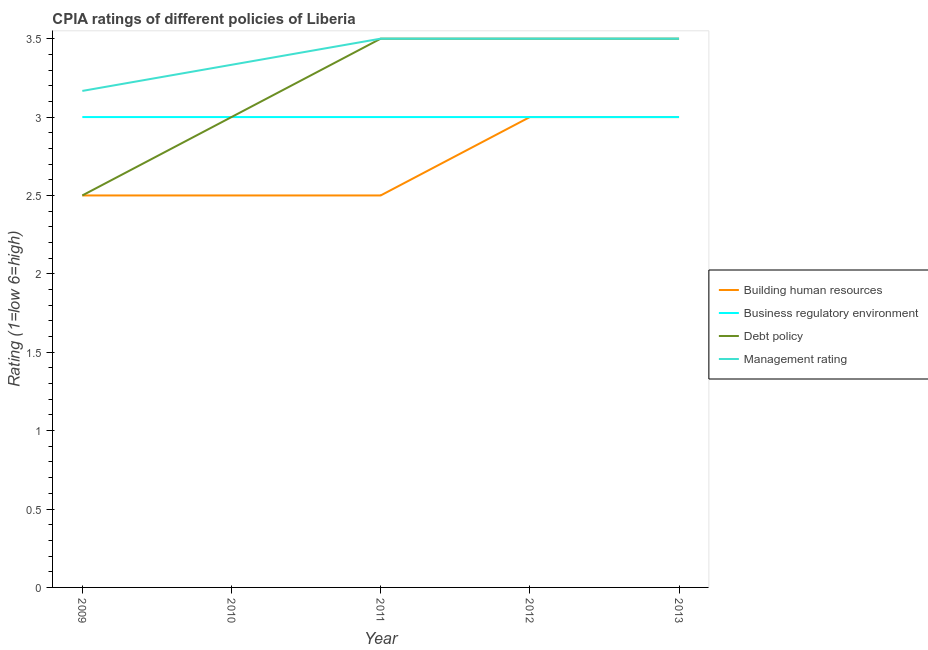How many different coloured lines are there?
Give a very brief answer. 4. Does the line corresponding to cpia rating of debt policy intersect with the line corresponding to cpia rating of management?
Provide a short and direct response. Yes. Across all years, what is the maximum cpia rating of management?
Your response must be concise. 3.5. Across all years, what is the minimum cpia rating of business regulatory environment?
Provide a succinct answer. 3. What is the difference between the cpia rating of building human resources in 2009 and that in 2012?
Offer a terse response. -0.5. What is the ratio of the cpia rating of business regulatory environment in 2011 to that in 2013?
Provide a short and direct response. 1. Is the difference between the cpia rating of building human resources in 2010 and 2011 greater than the difference between the cpia rating of management in 2010 and 2011?
Your answer should be very brief. Yes. What is the difference between the highest and the second highest cpia rating of building human resources?
Your answer should be compact. 0. What is the difference between the highest and the lowest cpia rating of debt policy?
Give a very brief answer. 1. In how many years, is the cpia rating of management greater than the average cpia rating of management taken over all years?
Your answer should be compact. 3. Is the sum of the cpia rating of building human resources in 2011 and 2012 greater than the maximum cpia rating of business regulatory environment across all years?
Keep it short and to the point. Yes. Does the cpia rating of management monotonically increase over the years?
Your response must be concise. No. Is the cpia rating of building human resources strictly greater than the cpia rating of debt policy over the years?
Provide a succinct answer. No. Is the cpia rating of debt policy strictly less than the cpia rating of business regulatory environment over the years?
Make the answer very short. No. Are the values on the major ticks of Y-axis written in scientific E-notation?
Offer a very short reply. No. Does the graph contain grids?
Your answer should be very brief. No. Where does the legend appear in the graph?
Provide a succinct answer. Center right. How many legend labels are there?
Provide a short and direct response. 4. What is the title of the graph?
Keep it short and to the point. CPIA ratings of different policies of Liberia. Does "Business regulatory environment" appear as one of the legend labels in the graph?
Provide a short and direct response. Yes. What is the Rating (1=low 6=high) in Building human resources in 2009?
Offer a very short reply. 2.5. What is the Rating (1=low 6=high) in Business regulatory environment in 2009?
Your answer should be compact. 3. What is the Rating (1=low 6=high) of Management rating in 2009?
Offer a very short reply. 3.17. What is the Rating (1=low 6=high) in Debt policy in 2010?
Keep it short and to the point. 3. What is the Rating (1=low 6=high) in Management rating in 2010?
Your answer should be very brief. 3.33. What is the Rating (1=low 6=high) of Business regulatory environment in 2011?
Make the answer very short. 3. What is the Rating (1=low 6=high) of Debt policy in 2011?
Your response must be concise. 3.5. What is the Rating (1=low 6=high) in Management rating in 2011?
Make the answer very short. 3.5. What is the Rating (1=low 6=high) in Building human resources in 2012?
Offer a terse response. 3. What is the Rating (1=low 6=high) in Debt policy in 2012?
Make the answer very short. 3.5. What is the Rating (1=low 6=high) in Management rating in 2012?
Make the answer very short. 3.5. What is the Rating (1=low 6=high) of Building human resources in 2013?
Your answer should be compact. 3. What is the Rating (1=low 6=high) in Business regulatory environment in 2013?
Provide a succinct answer. 3. What is the Rating (1=low 6=high) of Management rating in 2013?
Offer a terse response. 3.5. Across all years, what is the maximum Rating (1=low 6=high) of Building human resources?
Offer a terse response. 3. Across all years, what is the maximum Rating (1=low 6=high) of Business regulatory environment?
Your response must be concise. 3. Across all years, what is the maximum Rating (1=low 6=high) in Debt policy?
Provide a succinct answer. 3.5. Across all years, what is the minimum Rating (1=low 6=high) in Building human resources?
Make the answer very short. 2.5. Across all years, what is the minimum Rating (1=low 6=high) of Debt policy?
Keep it short and to the point. 2.5. Across all years, what is the minimum Rating (1=low 6=high) in Management rating?
Your response must be concise. 3.17. What is the total Rating (1=low 6=high) in Building human resources in the graph?
Offer a terse response. 13.5. What is the total Rating (1=low 6=high) in Business regulatory environment in the graph?
Offer a terse response. 15. What is the difference between the Rating (1=low 6=high) of Business regulatory environment in 2009 and that in 2010?
Give a very brief answer. 0. What is the difference between the Rating (1=low 6=high) of Building human resources in 2009 and that in 2011?
Offer a terse response. 0. What is the difference between the Rating (1=low 6=high) of Business regulatory environment in 2009 and that in 2011?
Provide a succinct answer. 0. What is the difference between the Rating (1=low 6=high) of Debt policy in 2009 and that in 2011?
Ensure brevity in your answer.  -1. What is the difference between the Rating (1=low 6=high) of Debt policy in 2009 and that in 2012?
Your response must be concise. -1. What is the difference between the Rating (1=low 6=high) of Management rating in 2009 and that in 2012?
Your response must be concise. -0.33. What is the difference between the Rating (1=low 6=high) of Building human resources in 2010 and that in 2011?
Give a very brief answer. 0. What is the difference between the Rating (1=low 6=high) in Management rating in 2010 and that in 2011?
Ensure brevity in your answer.  -0.17. What is the difference between the Rating (1=low 6=high) of Management rating in 2010 and that in 2012?
Keep it short and to the point. -0.17. What is the difference between the Rating (1=low 6=high) of Business regulatory environment in 2010 and that in 2013?
Provide a succinct answer. 0. What is the difference between the Rating (1=low 6=high) of Building human resources in 2011 and that in 2012?
Offer a very short reply. -0.5. What is the difference between the Rating (1=low 6=high) of Management rating in 2011 and that in 2012?
Your answer should be compact. 0. What is the difference between the Rating (1=low 6=high) of Building human resources in 2011 and that in 2013?
Keep it short and to the point. -0.5. What is the difference between the Rating (1=low 6=high) in Business regulatory environment in 2011 and that in 2013?
Ensure brevity in your answer.  0. What is the difference between the Rating (1=low 6=high) of Building human resources in 2012 and that in 2013?
Your response must be concise. 0. What is the difference between the Rating (1=low 6=high) in Business regulatory environment in 2012 and that in 2013?
Keep it short and to the point. 0. What is the difference between the Rating (1=low 6=high) in Management rating in 2012 and that in 2013?
Give a very brief answer. 0. What is the difference between the Rating (1=low 6=high) in Building human resources in 2009 and the Rating (1=low 6=high) in Management rating in 2010?
Keep it short and to the point. -0.83. What is the difference between the Rating (1=low 6=high) in Business regulatory environment in 2009 and the Rating (1=low 6=high) in Management rating in 2010?
Give a very brief answer. -0.33. What is the difference between the Rating (1=low 6=high) of Building human resources in 2009 and the Rating (1=low 6=high) of Business regulatory environment in 2011?
Provide a short and direct response. -0.5. What is the difference between the Rating (1=low 6=high) in Building human resources in 2009 and the Rating (1=low 6=high) in Debt policy in 2011?
Keep it short and to the point. -1. What is the difference between the Rating (1=low 6=high) in Building human resources in 2009 and the Rating (1=low 6=high) in Business regulatory environment in 2012?
Give a very brief answer. -0.5. What is the difference between the Rating (1=low 6=high) in Building human resources in 2009 and the Rating (1=low 6=high) in Debt policy in 2012?
Provide a succinct answer. -1. What is the difference between the Rating (1=low 6=high) of Building human resources in 2009 and the Rating (1=low 6=high) of Management rating in 2012?
Keep it short and to the point. -1. What is the difference between the Rating (1=low 6=high) of Business regulatory environment in 2009 and the Rating (1=low 6=high) of Debt policy in 2012?
Keep it short and to the point. -0.5. What is the difference between the Rating (1=low 6=high) in Business regulatory environment in 2009 and the Rating (1=low 6=high) in Management rating in 2012?
Provide a short and direct response. -0.5. What is the difference between the Rating (1=low 6=high) of Business regulatory environment in 2009 and the Rating (1=low 6=high) of Management rating in 2013?
Provide a short and direct response. -0.5. What is the difference between the Rating (1=low 6=high) of Building human resources in 2010 and the Rating (1=low 6=high) of Business regulatory environment in 2011?
Provide a succinct answer. -0.5. What is the difference between the Rating (1=low 6=high) of Building human resources in 2010 and the Rating (1=low 6=high) of Management rating in 2011?
Keep it short and to the point. -1. What is the difference between the Rating (1=low 6=high) in Business regulatory environment in 2010 and the Rating (1=low 6=high) in Debt policy in 2011?
Provide a succinct answer. -0.5. What is the difference between the Rating (1=low 6=high) of Building human resources in 2010 and the Rating (1=low 6=high) of Business regulatory environment in 2012?
Give a very brief answer. -0.5. What is the difference between the Rating (1=low 6=high) in Debt policy in 2010 and the Rating (1=low 6=high) in Management rating in 2012?
Provide a short and direct response. -0.5. What is the difference between the Rating (1=low 6=high) of Building human resources in 2010 and the Rating (1=low 6=high) of Business regulatory environment in 2013?
Keep it short and to the point. -0.5. What is the difference between the Rating (1=low 6=high) in Building human resources in 2011 and the Rating (1=low 6=high) in Business regulatory environment in 2012?
Give a very brief answer. -0.5. What is the difference between the Rating (1=low 6=high) of Business regulatory environment in 2011 and the Rating (1=low 6=high) of Debt policy in 2012?
Your answer should be very brief. -0.5. What is the difference between the Rating (1=low 6=high) of Business regulatory environment in 2011 and the Rating (1=low 6=high) of Management rating in 2012?
Keep it short and to the point. -0.5. What is the difference between the Rating (1=low 6=high) of Building human resources in 2011 and the Rating (1=low 6=high) of Management rating in 2013?
Give a very brief answer. -1. What is the difference between the Rating (1=low 6=high) in Business regulatory environment in 2011 and the Rating (1=low 6=high) in Debt policy in 2013?
Your answer should be compact. -0.5. What is the difference between the Rating (1=low 6=high) of Business regulatory environment in 2011 and the Rating (1=low 6=high) of Management rating in 2013?
Your answer should be compact. -0.5. What is the difference between the Rating (1=low 6=high) in Debt policy in 2011 and the Rating (1=low 6=high) in Management rating in 2013?
Your answer should be very brief. 0. What is the difference between the Rating (1=low 6=high) in Business regulatory environment in 2012 and the Rating (1=low 6=high) in Debt policy in 2013?
Provide a short and direct response. -0.5. What is the average Rating (1=low 6=high) of Building human resources per year?
Offer a very short reply. 2.7. In the year 2009, what is the difference between the Rating (1=low 6=high) in Building human resources and Rating (1=low 6=high) in Debt policy?
Keep it short and to the point. 0. In the year 2009, what is the difference between the Rating (1=low 6=high) of Business regulatory environment and Rating (1=low 6=high) of Debt policy?
Make the answer very short. 0.5. In the year 2009, what is the difference between the Rating (1=low 6=high) of Business regulatory environment and Rating (1=low 6=high) of Management rating?
Your answer should be compact. -0.17. In the year 2010, what is the difference between the Rating (1=low 6=high) in Building human resources and Rating (1=low 6=high) in Management rating?
Make the answer very short. -0.83. In the year 2010, what is the difference between the Rating (1=low 6=high) of Business regulatory environment and Rating (1=low 6=high) of Management rating?
Your response must be concise. -0.33. In the year 2011, what is the difference between the Rating (1=low 6=high) of Building human resources and Rating (1=low 6=high) of Debt policy?
Keep it short and to the point. -1. In the year 2011, what is the difference between the Rating (1=low 6=high) of Debt policy and Rating (1=low 6=high) of Management rating?
Your response must be concise. 0. In the year 2012, what is the difference between the Rating (1=low 6=high) of Building human resources and Rating (1=low 6=high) of Debt policy?
Your answer should be very brief. -0.5. In the year 2012, what is the difference between the Rating (1=low 6=high) in Building human resources and Rating (1=low 6=high) in Management rating?
Provide a succinct answer. -0.5. In the year 2012, what is the difference between the Rating (1=low 6=high) in Business regulatory environment and Rating (1=low 6=high) in Management rating?
Your answer should be very brief. -0.5. In the year 2012, what is the difference between the Rating (1=low 6=high) in Debt policy and Rating (1=low 6=high) in Management rating?
Give a very brief answer. 0. In the year 2013, what is the difference between the Rating (1=low 6=high) in Building human resources and Rating (1=low 6=high) in Business regulatory environment?
Ensure brevity in your answer.  0. In the year 2013, what is the difference between the Rating (1=low 6=high) in Building human resources and Rating (1=low 6=high) in Debt policy?
Offer a very short reply. -0.5. In the year 2013, what is the difference between the Rating (1=low 6=high) in Business regulatory environment and Rating (1=low 6=high) in Debt policy?
Offer a terse response. -0.5. What is the ratio of the Rating (1=low 6=high) in Building human resources in 2009 to that in 2010?
Provide a succinct answer. 1. What is the ratio of the Rating (1=low 6=high) in Business regulatory environment in 2009 to that in 2010?
Provide a succinct answer. 1. What is the ratio of the Rating (1=low 6=high) in Debt policy in 2009 to that in 2010?
Provide a succinct answer. 0.83. What is the ratio of the Rating (1=low 6=high) of Building human resources in 2009 to that in 2011?
Your response must be concise. 1. What is the ratio of the Rating (1=low 6=high) in Debt policy in 2009 to that in 2011?
Your answer should be very brief. 0.71. What is the ratio of the Rating (1=low 6=high) in Management rating in 2009 to that in 2011?
Give a very brief answer. 0.9. What is the ratio of the Rating (1=low 6=high) in Building human resources in 2009 to that in 2012?
Offer a very short reply. 0.83. What is the ratio of the Rating (1=low 6=high) in Management rating in 2009 to that in 2012?
Make the answer very short. 0.9. What is the ratio of the Rating (1=low 6=high) in Management rating in 2009 to that in 2013?
Your answer should be compact. 0.9. What is the ratio of the Rating (1=low 6=high) in Building human resources in 2010 to that in 2011?
Your answer should be compact. 1. What is the ratio of the Rating (1=low 6=high) in Debt policy in 2010 to that in 2012?
Your response must be concise. 0.86. What is the ratio of the Rating (1=low 6=high) of Management rating in 2010 to that in 2013?
Your response must be concise. 0.95. What is the ratio of the Rating (1=low 6=high) in Building human resources in 2011 to that in 2013?
Provide a succinct answer. 0.83. What is the ratio of the Rating (1=low 6=high) in Debt policy in 2011 to that in 2013?
Ensure brevity in your answer.  1. What is the ratio of the Rating (1=low 6=high) in Business regulatory environment in 2012 to that in 2013?
Give a very brief answer. 1. What is the difference between the highest and the second highest Rating (1=low 6=high) of Building human resources?
Provide a short and direct response. 0. What is the difference between the highest and the second highest Rating (1=low 6=high) in Debt policy?
Provide a short and direct response. 0. What is the difference between the highest and the lowest Rating (1=low 6=high) of Building human resources?
Your response must be concise. 0.5. What is the difference between the highest and the lowest Rating (1=low 6=high) of Debt policy?
Your response must be concise. 1. 